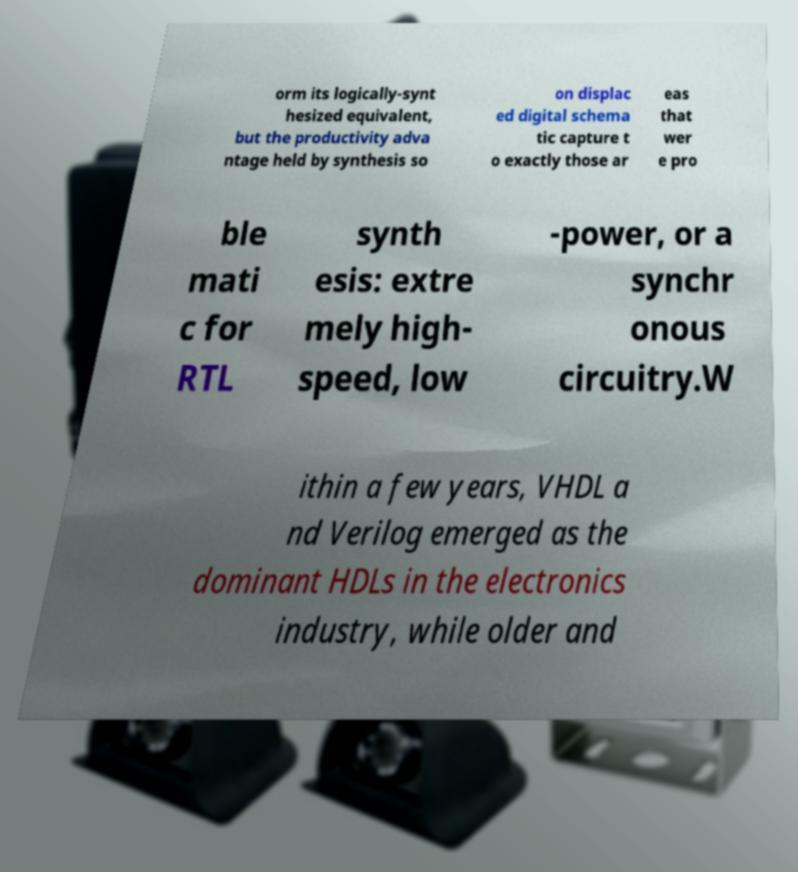Can you accurately transcribe the text from the provided image for me? orm its logically-synt hesized equivalent, but the productivity adva ntage held by synthesis so on displac ed digital schema tic capture t o exactly those ar eas that wer e pro ble mati c for RTL synth esis: extre mely high- speed, low -power, or a synchr onous circuitry.W ithin a few years, VHDL a nd Verilog emerged as the dominant HDLs in the electronics industry, while older and 